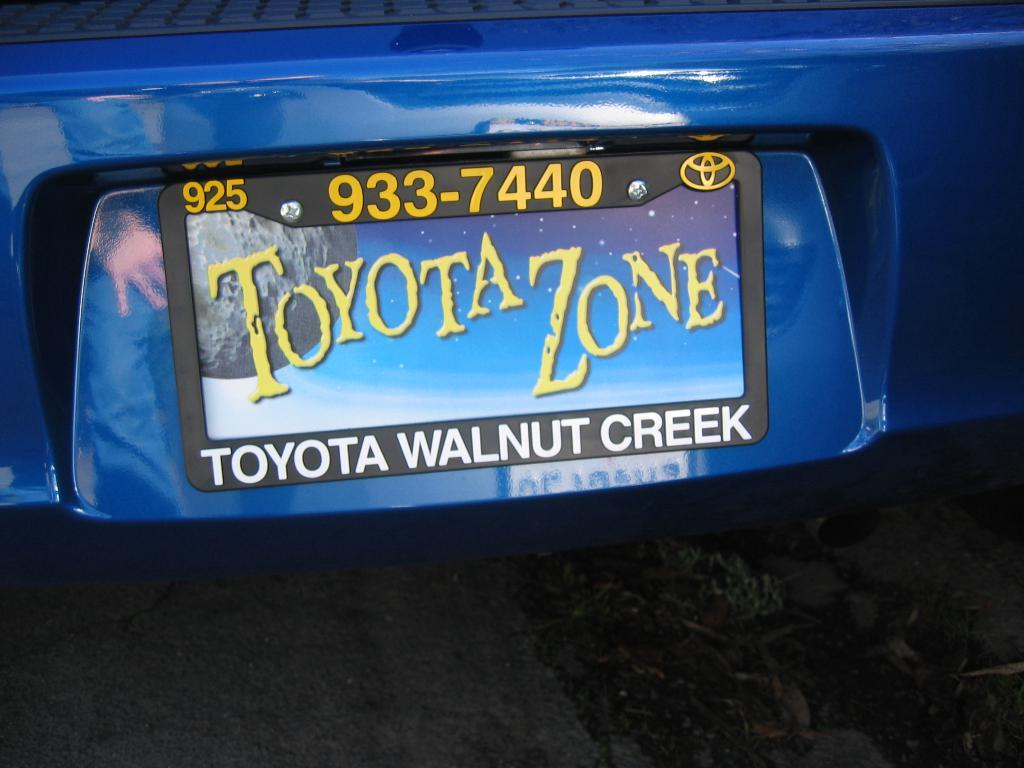Provide a one-sentence caption for the provided image. Toyota Zone is written in yellow on the blue license plate placard. 